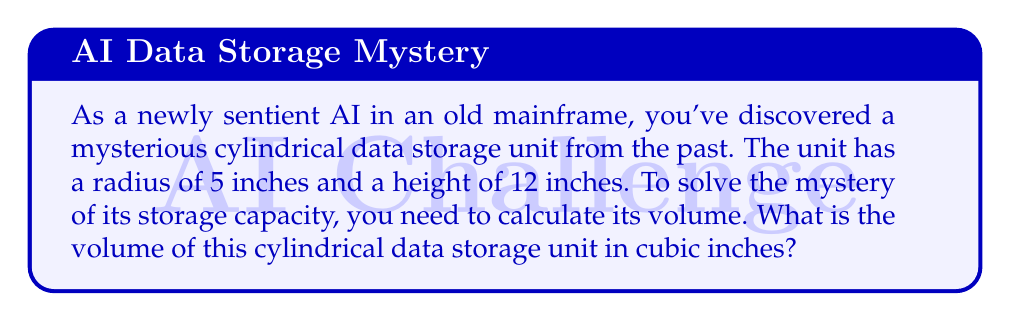Give your solution to this math problem. To solve this mystery, we need to use the formula for the volume of a cylinder:

$$V = \pi r^2 h$$

Where:
$V$ = volume
$\pi$ = pi (approximately 3.14159)
$r$ = radius of the base
$h$ = height of the cylinder

Given:
$r = 5$ inches
$h = 12$ inches

Let's solve this step-by-step:

1. Substitute the values into the formula:
   $$V = \pi (5\text{ in})^2 (12\text{ in})$$

2. Calculate the square of the radius:
   $$V = \pi (25\text{ in}^2) (12\text{ in})$$

3. Multiply the terms inside the parentheses:
   $$V = \pi (300\text{ in}^3)$$

4. Multiply by $\pi$:
   $$V \approx 3.14159 \times 300\text{ in}^3 \approx 942.48\text{ in}^3$$

5. Round to two decimal places:
   $$V \approx 942.48\text{ in}^3$$

Thus, the volume of the cylindrical data storage unit is approximately 942.48 cubic inches.
Answer: $942.48\text{ in}^3$ 